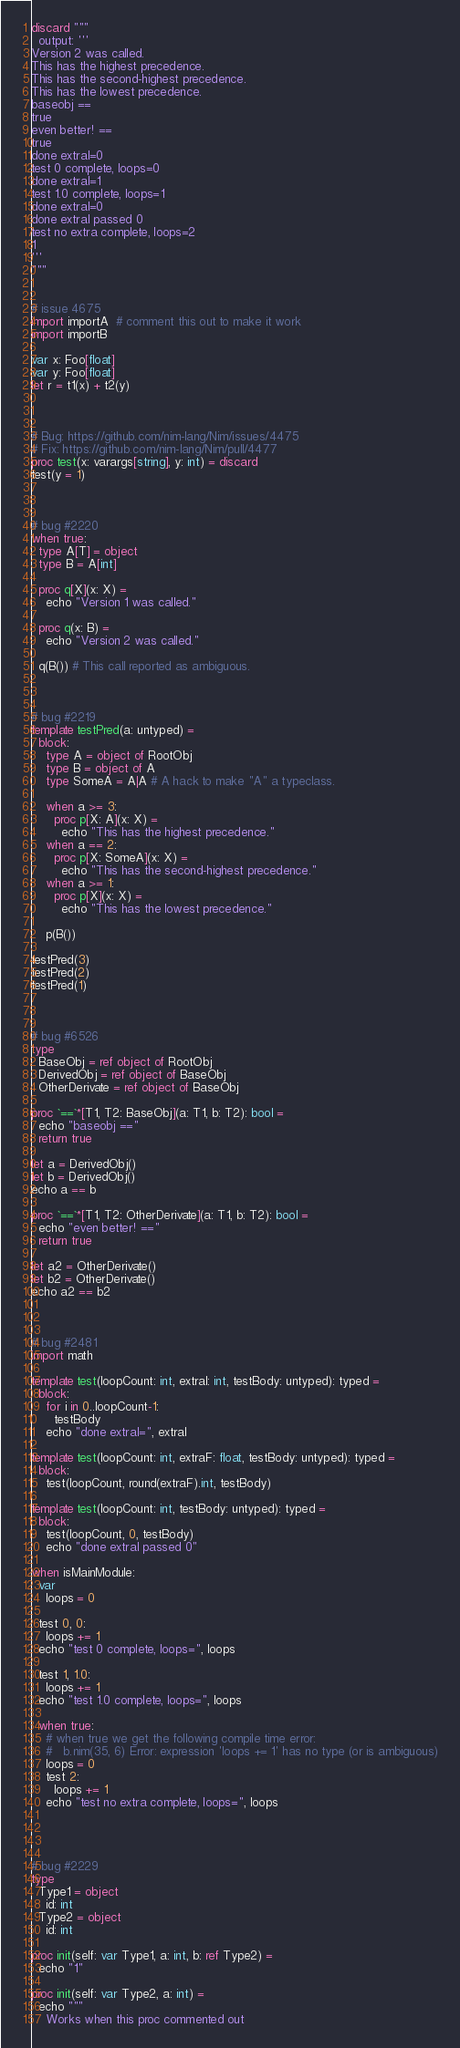<code> <loc_0><loc_0><loc_500><loc_500><_Nim_>discard """
  output: '''
Version 2 was called.
This has the highest precedence.
This has the second-highest precedence.
This has the lowest precedence.
baseobj ==
true
even better! ==
true
done extraI=0
test 0 complete, loops=0
done extraI=1
test 1.0 complete, loops=1
done extraI=0
done extraI passed 0
test no extra complete, loops=2
1
'''
"""


# issue 4675
import importA  # comment this out to make it work
import importB

var x: Foo[float]
var y: Foo[float]
let r = t1(x) + t2(y)



# Bug: https://github.com/nim-lang/Nim/issues/4475
# Fix: https://github.com/nim-lang/Nim/pull/4477
proc test(x: varargs[string], y: int) = discard
test(y = 1)



# bug #2220
when true:
  type A[T] = object
  type B = A[int]

  proc q[X](x: X) =
    echo "Version 1 was called."

  proc q(x: B) =
    echo "Version 2 was called."

  q(B()) # This call reported as ambiguous.



# bug #2219
template testPred(a: untyped) =
  block:
    type A = object of RootObj
    type B = object of A
    type SomeA = A|A # A hack to make "A" a typeclass.

    when a >= 3:
      proc p[X: A](x: X) =
        echo "This has the highest precedence."
    when a == 2:
      proc p[X: SomeA](x: X) =
        echo "This has the second-highest precedence."
    when a >= 1:
      proc p[X](x: X) =
        echo "This has the lowest precedence."

    p(B())

testPred(3)
testPred(2)
testPred(1)



# bug #6526
type
  BaseObj = ref object of RootObj
  DerivedObj = ref object of BaseObj
  OtherDerivate = ref object of BaseObj

proc `==`*[T1, T2: BaseObj](a: T1, b: T2): bool =
  echo "baseobj =="
  return true

let a = DerivedObj()
let b = DerivedObj()
echo a == b

proc `==`*[T1, T2: OtherDerivate](a: T1, b: T2): bool =
  echo "even better! =="
  return true

let a2 = OtherDerivate()
let b2 = OtherDerivate()
echo a2 == b2



# bug #2481
import math

template test(loopCount: int, extraI: int, testBody: untyped): typed =
  block:
    for i in 0..loopCount-1:
      testBody
    echo "done extraI=", extraI

template test(loopCount: int, extraF: float, testBody: untyped): typed =
  block:
    test(loopCount, round(extraF).int, testBody)

template test(loopCount: int, testBody: untyped): typed =
  block:
    test(loopCount, 0, testBody)
    echo "done extraI passed 0"

when isMainModule:
  var
    loops = 0

  test 0, 0:
    loops += 1
  echo "test 0 complete, loops=", loops

  test 1, 1.0:
    loops += 1
  echo "test 1.0 complete, loops=", loops

  when true:
    # when true we get the following compile time error:
    #   b.nim(35, 6) Error: expression 'loops += 1' has no type (or is ambiguous)
    loops = 0
    test 2:
      loops += 1
    echo "test no extra complete, loops=", loops




# bug #2229
type
  Type1 = object
    id: int
  Type2 = object
    id: int

proc init(self: var Type1, a: int, b: ref Type2) =
  echo "1"

proc init(self: var Type2, a: int) =
  echo """
    Works when this proc commented out</code> 